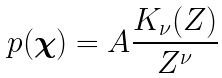Convert formula to latex. <formula><loc_0><loc_0><loc_500><loc_500>p ( \boldsymbol \chi ) = A \frac { K _ { \nu } ( Z ) } { Z ^ { \nu } }</formula> 